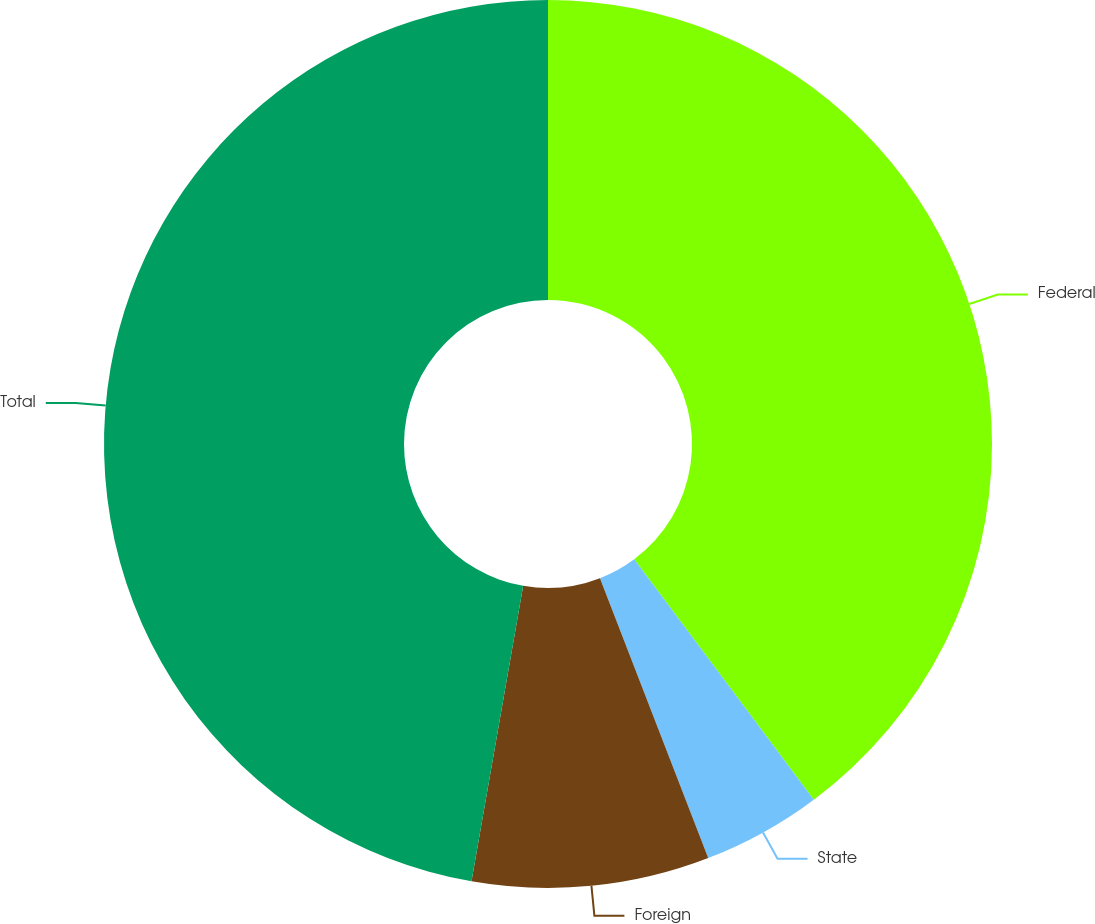Convert chart to OTSL. <chart><loc_0><loc_0><loc_500><loc_500><pie_chart><fcel>Federal<fcel>State<fcel>Foreign<fcel>Total<nl><fcel>39.78%<fcel>4.34%<fcel>8.63%<fcel>47.24%<nl></chart> 